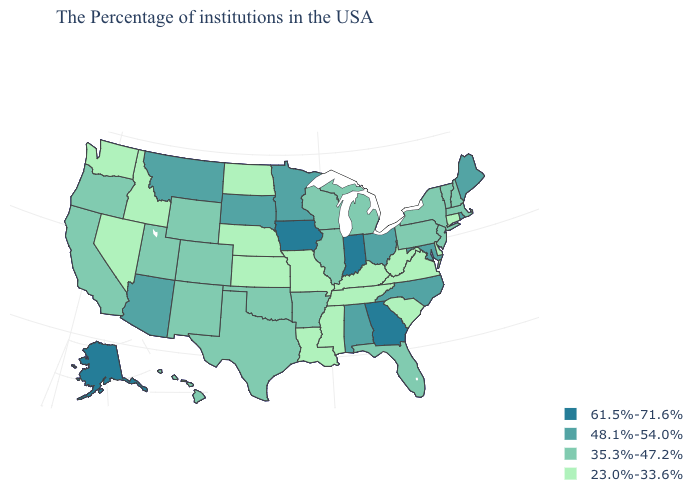What is the value of New York?
Give a very brief answer. 35.3%-47.2%. What is the value of Hawaii?
Quick response, please. 35.3%-47.2%. Name the states that have a value in the range 35.3%-47.2%?
Give a very brief answer. Massachusetts, New Hampshire, Vermont, New York, New Jersey, Pennsylvania, Florida, Michigan, Wisconsin, Illinois, Arkansas, Oklahoma, Texas, Wyoming, Colorado, New Mexico, Utah, California, Oregon, Hawaii. Name the states that have a value in the range 23.0%-33.6%?
Short answer required. Connecticut, Delaware, Virginia, South Carolina, West Virginia, Kentucky, Tennessee, Mississippi, Louisiana, Missouri, Kansas, Nebraska, North Dakota, Idaho, Nevada, Washington. Does North Carolina have the same value as Ohio?
Give a very brief answer. Yes. Which states have the highest value in the USA?
Keep it brief. Georgia, Indiana, Iowa, Alaska. What is the lowest value in the USA?
Answer briefly. 23.0%-33.6%. Which states have the highest value in the USA?
Concise answer only. Georgia, Indiana, Iowa, Alaska. Name the states that have a value in the range 61.5%-71.6%?
Give a very brief answer. Georgia, Indiana, Iowa, Alaska. Does Oregon have the lowest value in the USA?
Give a very brief answer. No. Which states have the highest value in the USA?
Give a very brief answer. Georgia, Indiana, Iowa, Alaska. Name the states that have a value in the range 35.3%-47.2%?
Write a very short answer. Massachusetts, New Hampshire, Vermont, New York, New Jersey, Pennsylvania, Florida, Michigan, Wisconsin, Illinois, Arkansas, Oklahoma, Texas, Wyoming, Colorado, New Mexico, Utah, California, Oregon, Hawaii. Does Ohio have a lower value than Iowa?
Keep it brief. Yes. Which states have the lowest value in the West?
Give a very brief answer. Idaho, Nevada, Washington. Among the states that border Wyoming , does South Dakota have the lowest value?
Quick response, please. No. 